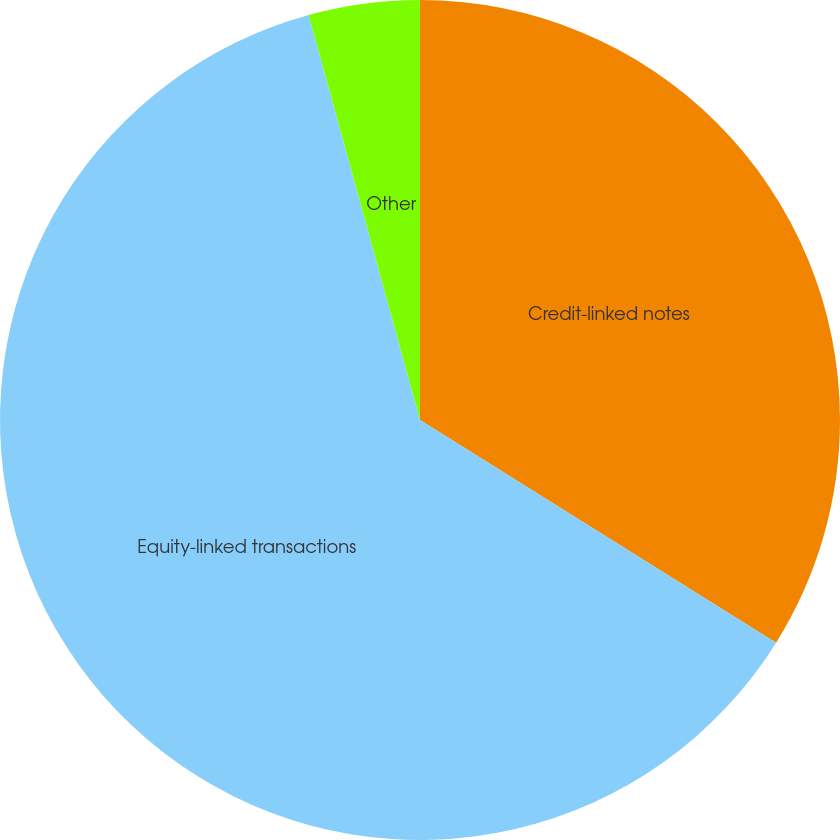<chart> <loc_0><loc_0><loc_500><loc_500><pie_chart><fcel>Credit-linked notes<fcel>Equity-linked transactions<fcel>Other<nl><fcel>33.89%<fcel>61.83%<fcel>4.27%<nl></chart> 